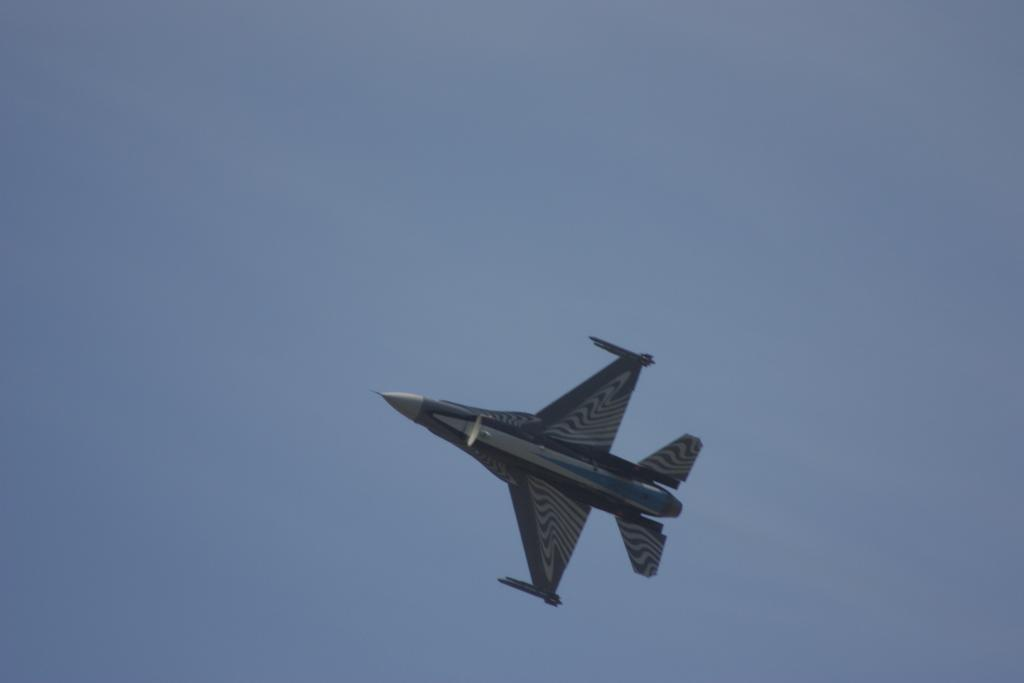What is the main subject of the image? The main subject of the image is a jet plane. What colors are used to depict the jet plane? The jet plane is in black and grey color. What is the jet plane doing in the image? The jet plane is flying in the sky. What can be seen in the background of the image? The sky is visible in the background of the image. What is the color of the sky in the image? The sky is blue in color. Can you see a lock attached to the jet plane in the image? There is no lock present on the jet plane in the image. Is there a snail crawling on the wing of the jet plane in the image? There is no snail present on the jet plane in the image. 